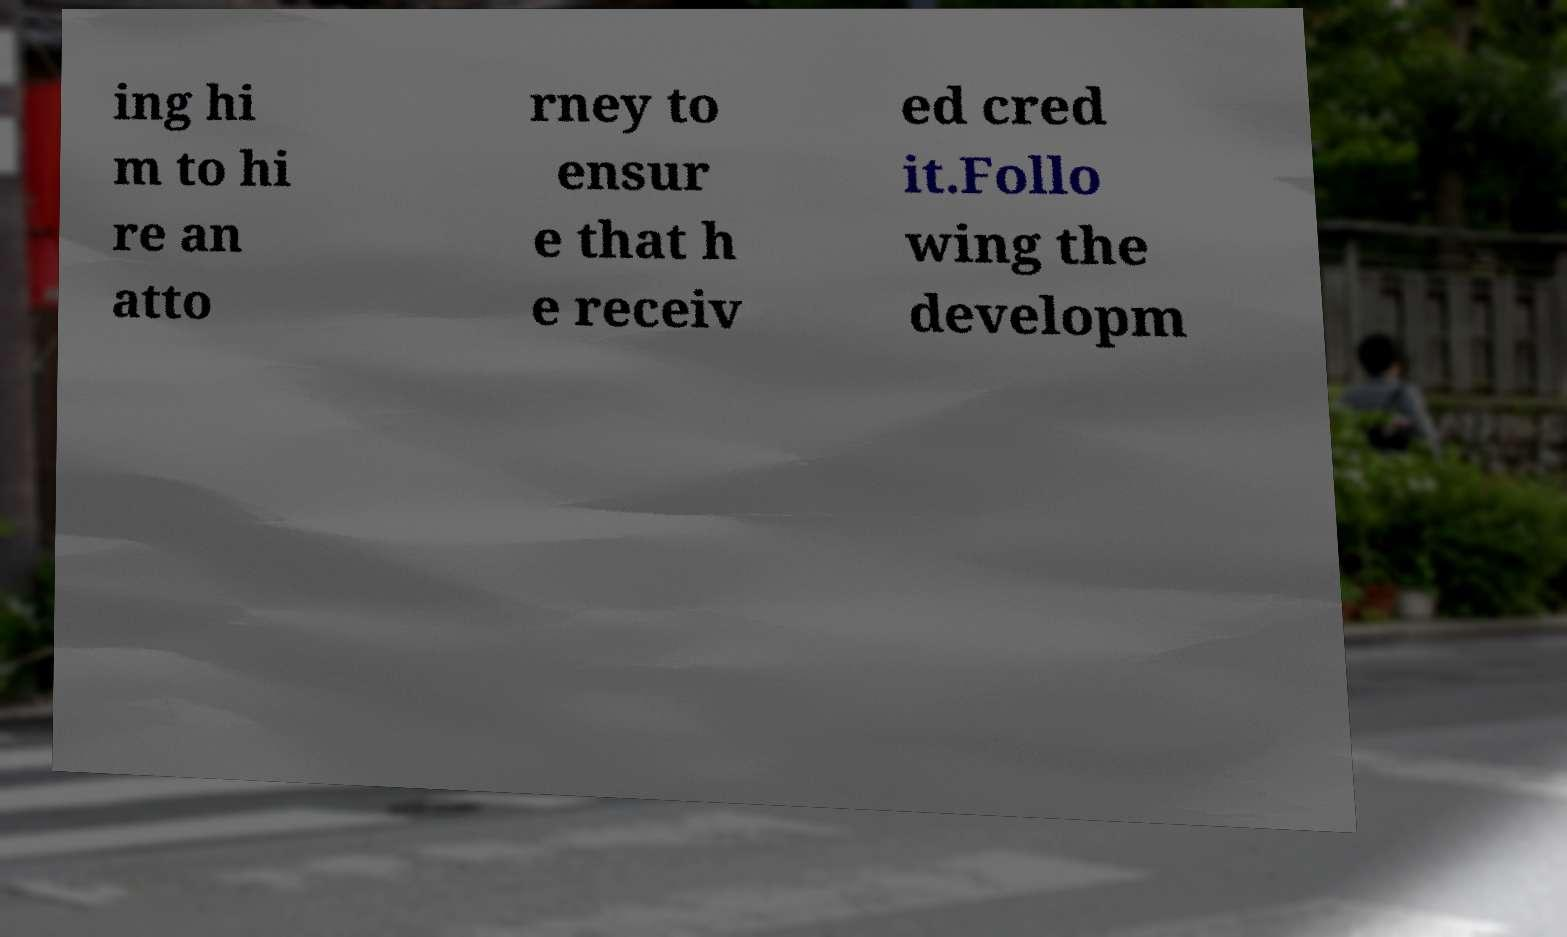Can you accurately transcribe the text from the provided image for me? ing hi m to hi re an atto rney to ensur e that h e receiv ed cred it.Follo wing the developm 